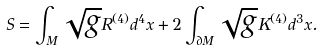<formula> <loc_0><loc_0><loc_500><loc_500>S = \int _ { M } \sqrt { g } R ^ { ( 4 ) } d ^ { 4 } x + 2 \int _ { \partial M } \sqrt { g } K ^ { ( 4 ) } d ^ { 3 } x .</formula> 